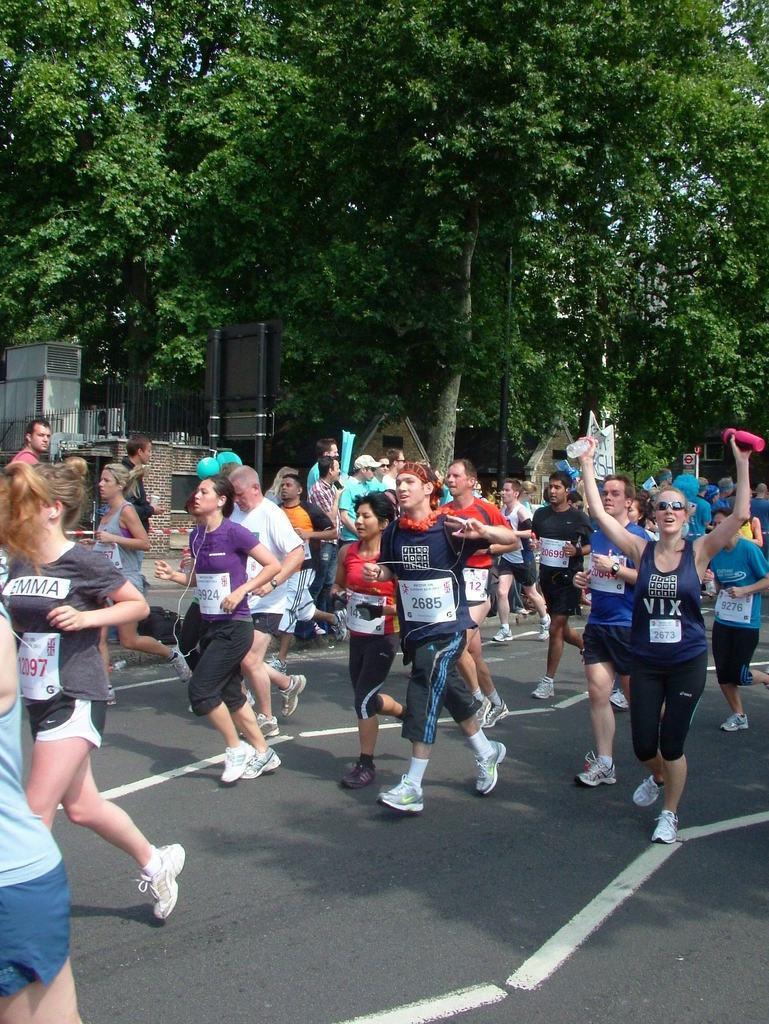Please provide a concise description of this image. In this picture we can see a group of people on the road and one woman is holding bottles and in the background we can see trees and some objects. 